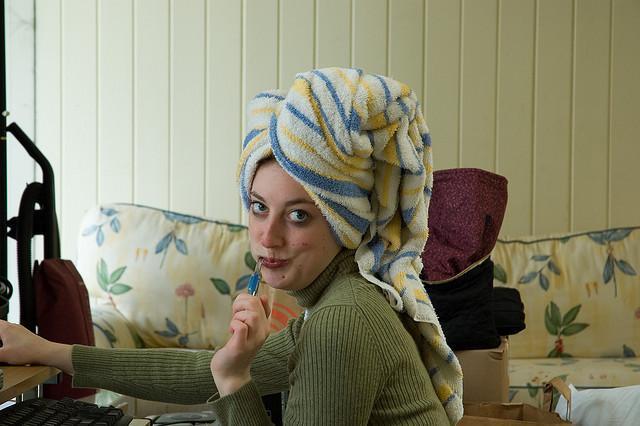Is the statement "The couch is under the person." accurate regarding the image?
Answer yes or no. No. 